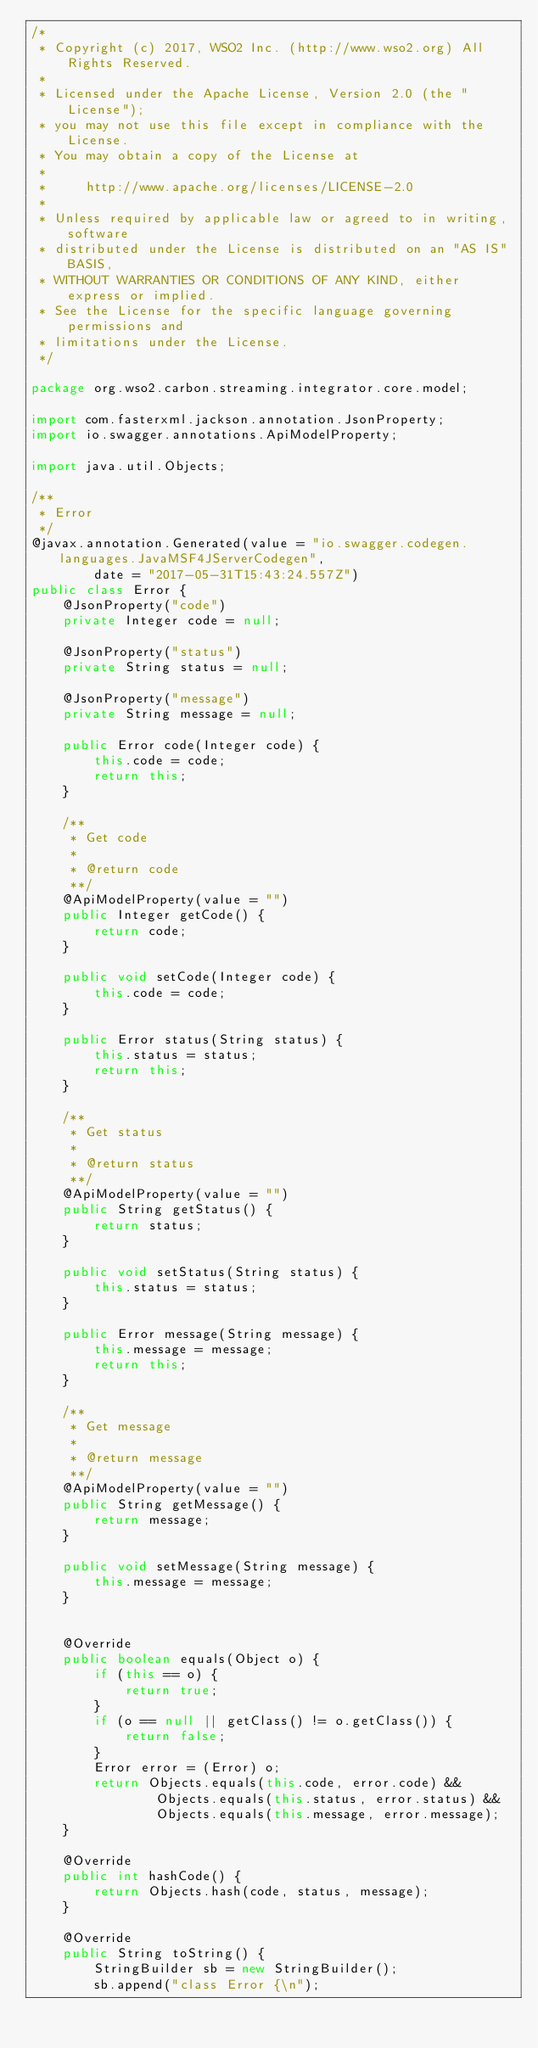<code> <loc_0><loc_0><loc_500><loc_500><_Java_>/*
 * Copyright (c) 2017, WSO2 Inc. (http://www.wso2.org) All Rights Reserved.
 *
 * Licensed under the Apache License, Version 2.0 (the "License");
 * you may not use this file except in compliance with the License.
 * You may obtain a copy of the License at
 *
 *     http://www.apache.org/licenses/LICENSE-2.0
 *
 * Unless required by applicable law or agreed to in writing, software
 * distributed under the License is distributed on an "AS IS" BASIS,
 * WITHOUT WARRANTIES OR CONDITIONS OF ANY KIND, either express or implied.
 * See the License for the specific language governing permissions and
 * limitations under the License.
 */

package org.wso2.carbon.streaming.integrator.core.model;

import com.fasterxml.jackson.annotation.JsonProperty;
import io.swagger.annotations.ApiModelProperty;

import java.util.Objects;

/**
 * Error
 */
@javax.annotation.Generated(value = "io.swagger.codegen.languages.JavaMSF4JServerCodegen",
        date = "2017-05-31T15:43:24.557Z")
public class Error {
    @JsonProperty("code")
    private Integer code = null;

    @JsonProperty("status")
    private String status = null;

    @JsonProperty("message")
    private String message = null;

    public Error code(Integer code) {
        this.code = code;
        return this;
    }

    /**
     * Get code
     *
     * @return code
     **/
    @ApiModelProperty(value = "")
    public Integer getCode() {
        return code;
    }

    public void setCode(Integer code) {
        this.code = code;
    }

    public Error status(String status) {
        this.status = status;
        return this;
    }

    /**
     * Get status
     *
     * @return status
     **/
    @ApiModelProperty(value = "")
    public String getStatus() {
        return status;
    }

    public void setStatus(String status) {
        this.status = status;
    }

    public Error message(String message) {
        this.message = message;
        return this;
    }

    /**
     * Get message
     *
     * @return message
     **/
    @ApiModelProperty(value = "")
    public String getMessage() {
        return message;
    }

    public void setMessage(String message) {
        this.message = message;
    }


    @Override
    public boolean equals(Object o) {
        if (this == o) {
            return true;
        }
        if (o == null || getClass() != o.getClass()) {
            return false;
        }
        Error error = (Error) o;
        return Objects.equals(this.code, error.code) &&
                Objects.equals(this.status, error.status) &&
                Objects.equals(this.message, error.message);
    }

    @Override
    public int hashCode() {
        return Objects.hash(code, status, message);
    }

    @Override
    public String toString() {
        StringBuilder sb = new StringBuilder();
        sb.append("class Error {\n");
</code> 